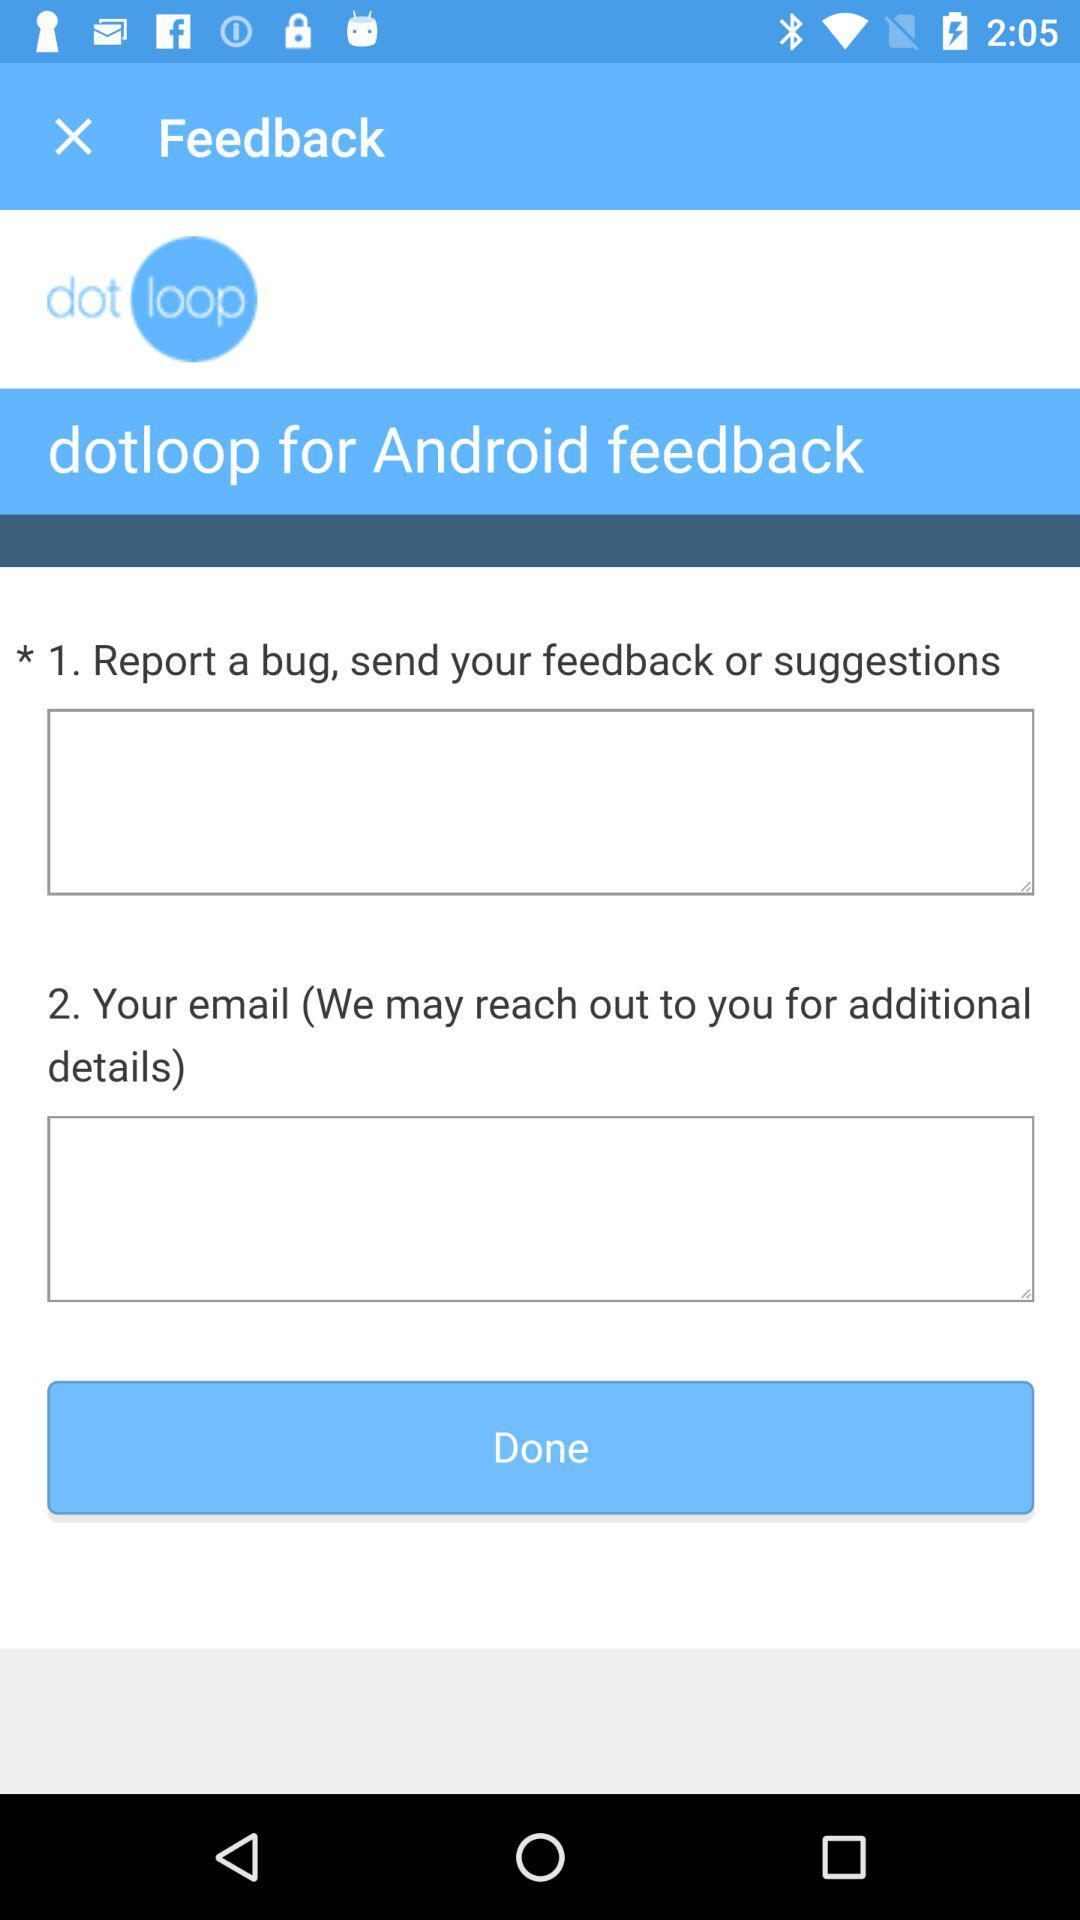What is the user's email?
When the provided information is insufficient, respond with <no answer>. <no answer> 